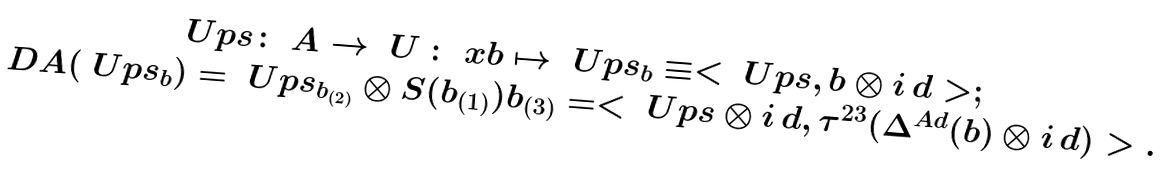Convert formula to latex. <formula><loc_0><loc_0><loc_500><loc_500>\begin{array} { c } \ U p s \colon \ A \to \ U \, \colon \ x b \mapsto \ U p s _ { b } \equiv < \ U p s , b \otimes i \, d > ; \\ \ D A ( \ U p s _ { b } ) = \ U p s _ { b _ { ( 2 ) } } \otimes S ( b _ { ( 1 ) } ) b _ { ( 3 ) } = < \ U p s \otimes i \, d , \tau ^ { 2 3 } ( \Delta ^ { A d } ( b ) \otimes i \, d ) > . \end{array}</formula> 